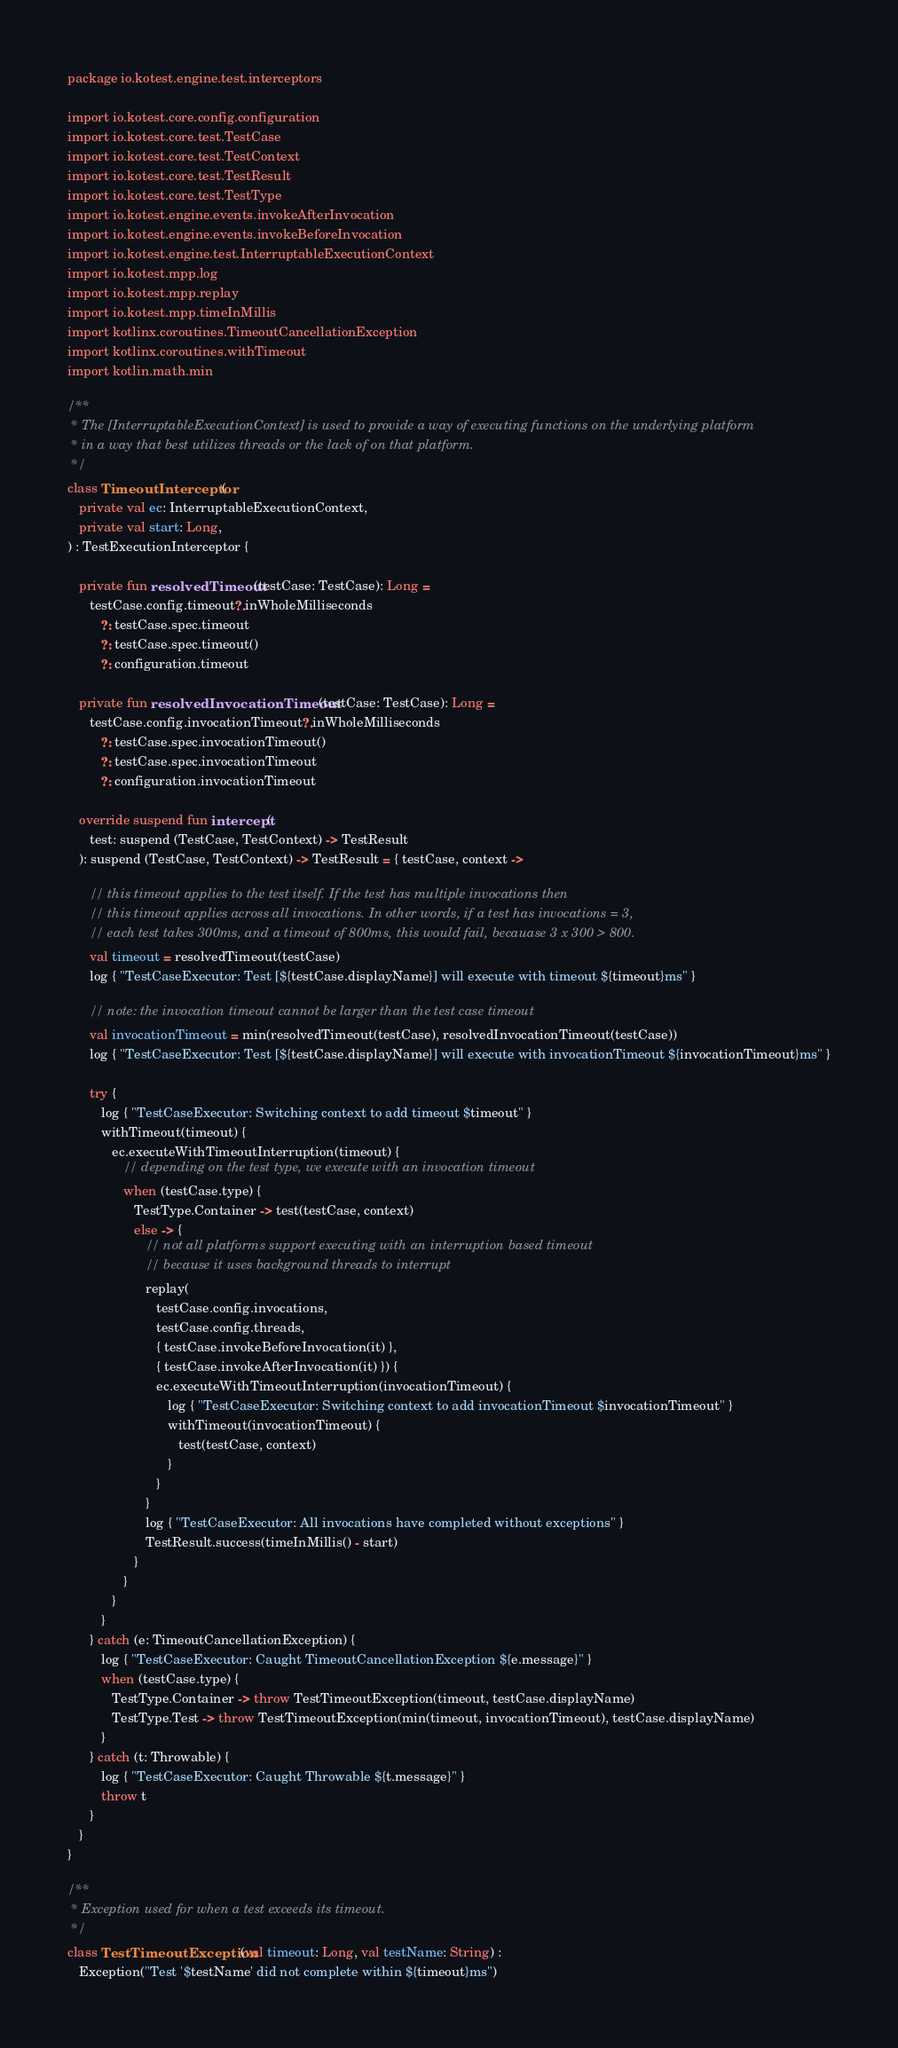<code> <loc_0><loc_0><loc_500><loc_500><_Kotlin_>package io.kotest.engine.test.interceptors

import io.kotest.core.config.configuration
import io.kotest.core.test.TestCase
import io.kotest.core.test.TestContext
import io.kotest.core.test.TestResult
import io.kotest.core.test.TestType
import io.kotest.engine.events.invokeAfterInvocation
import io.kotest.engine.events.invokeBeforeInvocation
import io.kotest.engine.test.InterruptableExecutionContext
import io.kotest.mpp.log
import io.kotest.mpp.replay
import io.kotest.mpp.timeInMillis
import kotlinx.coroutines.TimeoutCancellationException
import kotlinx.coroutines.withTimeout
import kotlin.math.min

/**
 * The [InterruptableExecutionContext] is used to provide a way of executing functions on the underlying platform
 * in a way that best utilizes threads or the lack of on that platform.
 */
class TimeoutInterceptor(
   private val ec: InterruptableExecutionContext,
   private val start: Long,
) : TestExecutionInterceptor {

   private fun resolvedTimeout(testCase: TestCase): Long =
      testCase.config.timeout?.inWholeMilliseconds
         ?: testCase.spec.timeout
         ?: testCase.spec.timeout()
         ?: configuration.timeout

   private fun resolvedInvocationTimeout(testCase: TestCase): Long =
      testCase.config.invocationTimeout?.inWholeMilliseconds
         ?: testCase.spec.invocationTimeout()
         ?: testCase.spec.invocationTimeout
         ?: configuration.invocationTimeout

   override suspend fun intercept(
      test: suspend (TestCase, TestContext) -> TestResult
   ): suspend (TestCase, TestContext) -> TestResult = { testCase, context ->

      // this timeout applies to the test itself. If the test has multiple invocations then
      // this timeout applies across all invocations. In other words, if a test has invocations = 3,
      // each test takes 300ms, and a timeout of 800ms, this would fail, becauase 3 x 300 > 800.
      val timeout = resolvedTimeout(testCase)
      log { "TestCaseExecutor: Test [${testCase.displayName}] will execute with timeout ${timeout}ms" }

      // note: the invocation timeout cannot be larger than the test case timeout
      val invocationTimeout = min(resolvedTimeout(testCase), resolvedInvocationTimeout(testCase))
      log { "TestCaseExecutor: Test [${testCase.displayName}] will execute with invocationTimeout ${invocationTimeout}ms" }

      try {
         log { "TestCaseExecutor: Switching context to add timeout $timeout" }
         withTimeout(timeout) {
            ec.executeWithTimeoutInterruption(timeout) {
               // depending on the test type, we execute with an invocation timeout
               when (testCase.type) {
                  TestType.Container -> test(testCase, context)
                  else -> {
                     // not all platforms support executing with an interruption based timeout
                     // because it uses background threads to interrupt
                     replay(
                        testCase.config.invocations,
                        testCase.config.threads,
                        { testCase.invokeBeforeInvocation(it) },
                        { testCase.invokeAfterInvocation(it) }) {
                        ec.executeWithTimeoutInterruption(invocationTimeout) {
                           log { "TestCaseExecutor: Switching context to add invocationTimeout $invocationTimeout" }
                           withTimeout(invocationTimeout) {
                              test(testCase, context)
                           }
                        }
                     }
                     log { "TestCaseExecutor: All invocations have completed without exceptions" }
                     TestResult.success(timeInMillis() - start)
                  }
               }
            }
         }
      } catch (e: TimeoutCancellationException) {
         log { "TestCaseExecutor: Caught TimeoutCancellationException ${e.message}" }
         when (testCase.type) {
            TestType.Container -> throw TestTimeoutException(timeout, testCase.displayName)
            TestType.Test -> throw TestTimeoutException(min(timeout, invocationTimeout), testCase.displayName)
         }
      } catch (t: Throwable) {
         log { "TestCaseExecutor: Caught Throwable ${t.message}" }
         throw t
      }
   }
}

/**
 * Exception used for when a test exceeds its timeout.
 */
class TestTimeoutException(val timeout: Long, val testName: String) :
   Exception("Test '$testName' did not complete within ${timeout}ms")
</code> 